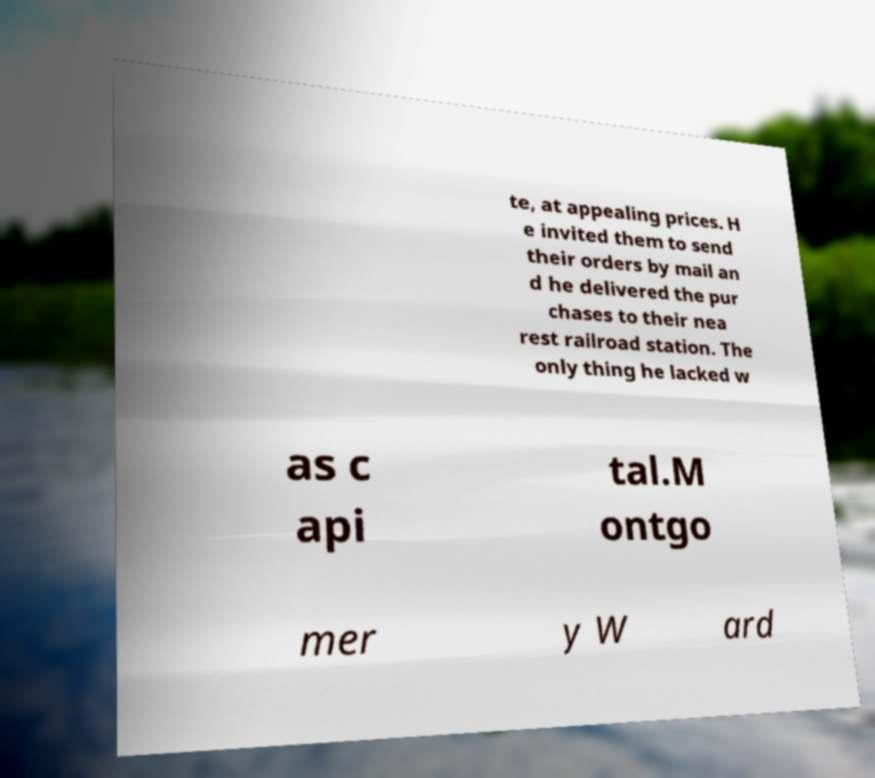Can you read and provide the text displayed in the image?This photo seems to have some interesting text. Can you extract and type it out for me? te, at appealing prices. H e invited them to send their orders by mail an d he delivered the pur chases to their nea rest railroad station. The only thing he lacked w as c api tal.M ontgo mer y W ard 